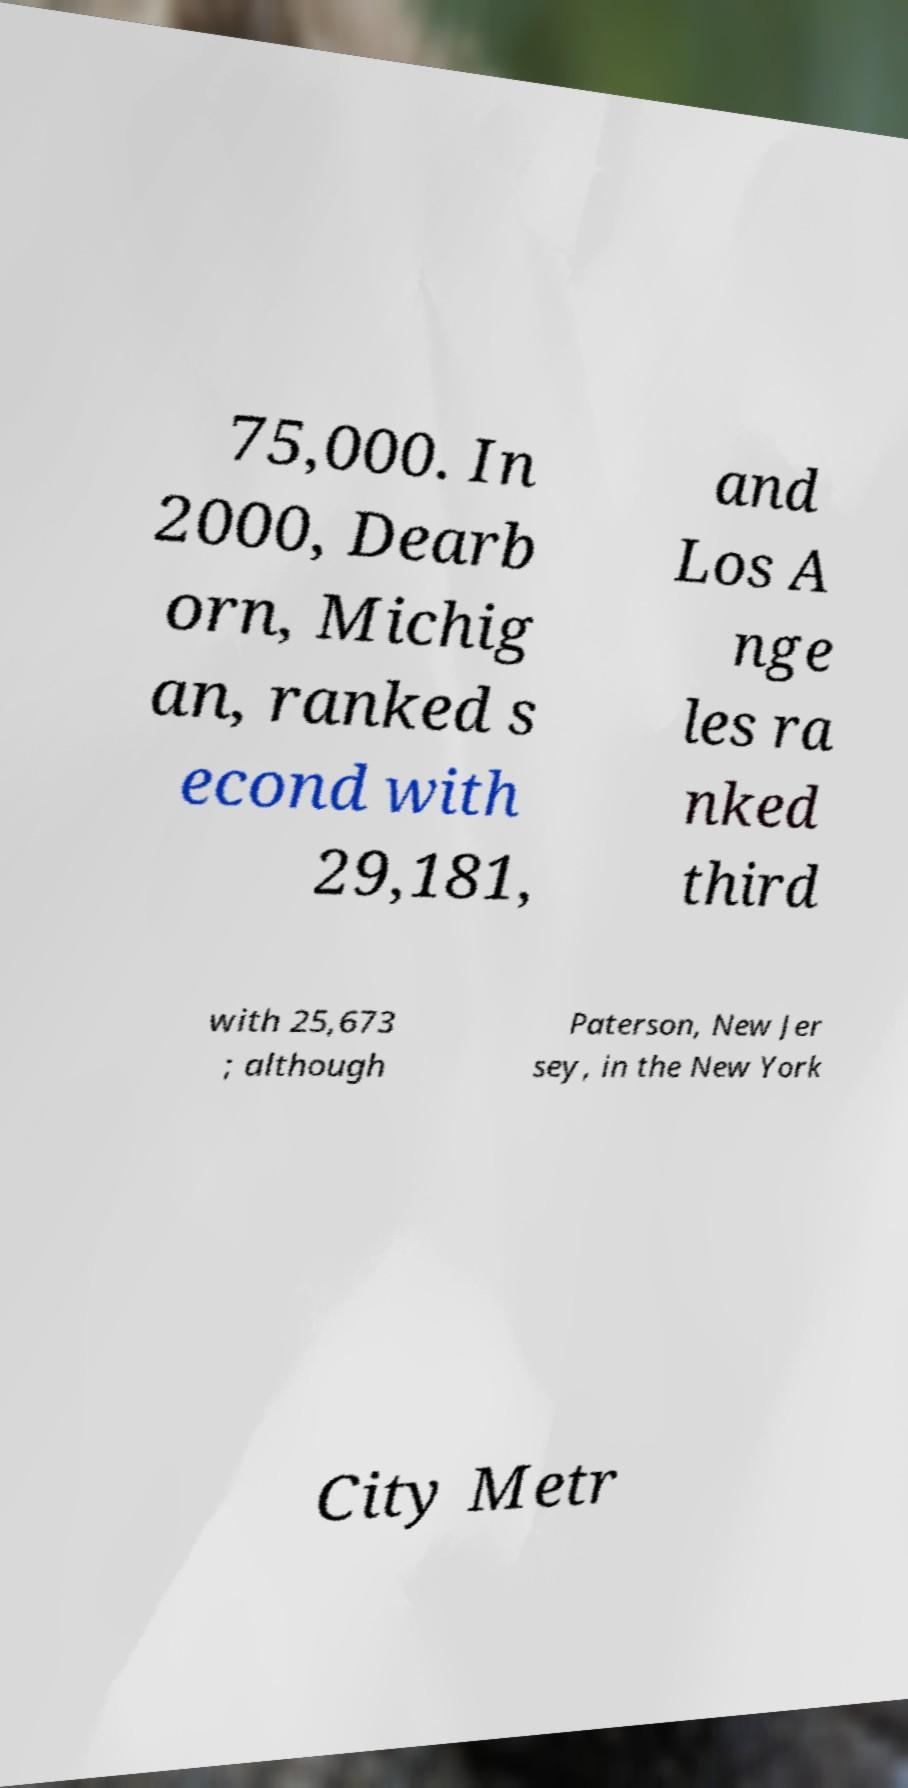There's text embedded in this image that I need extracted. Can you transcribe it verbatim? 75,000. In 2000, Dearb orn, Michig an, ranked s econd with 29,181, and Los A nge les ra nked third with 25,673 ; although Paterson, New Jer sey, in the New York City Metr 